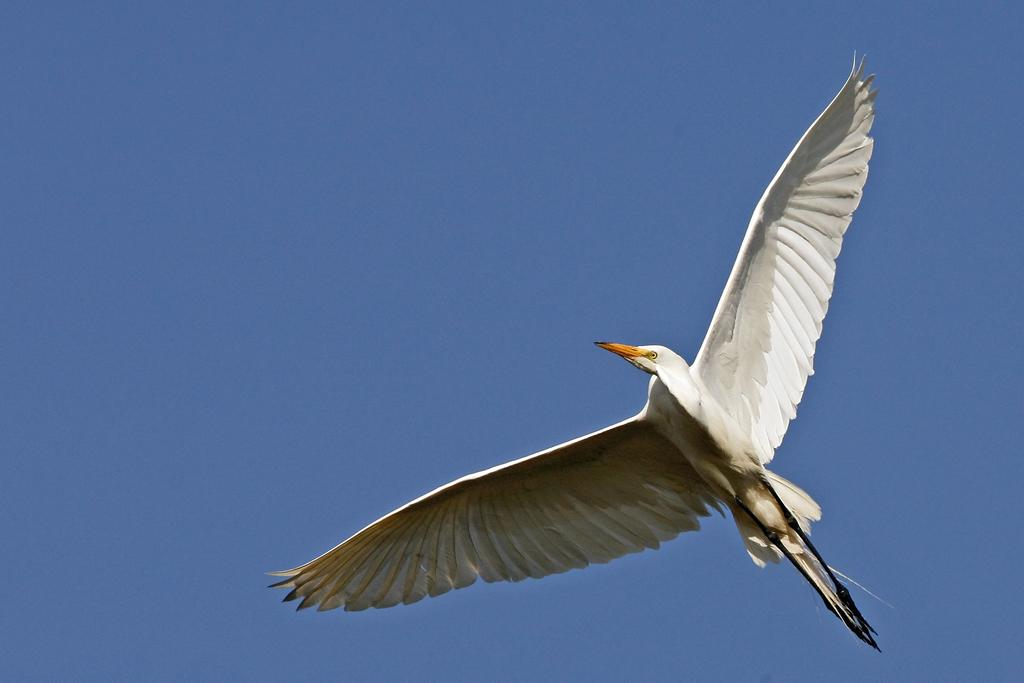What type of animal can be seen in the image? There is a bird in the image. What is the bird doing in the image? The bird is flying in the air. What can be seen in the background of the image? There is sky visible in the background of the image. Is the bird driving a car in the image? No, the bird is not driving a car in the image; it is flying in the air. What type of straw is being used by the bird in the image? There is no straw present in the image; it features a bird flying in the air. 